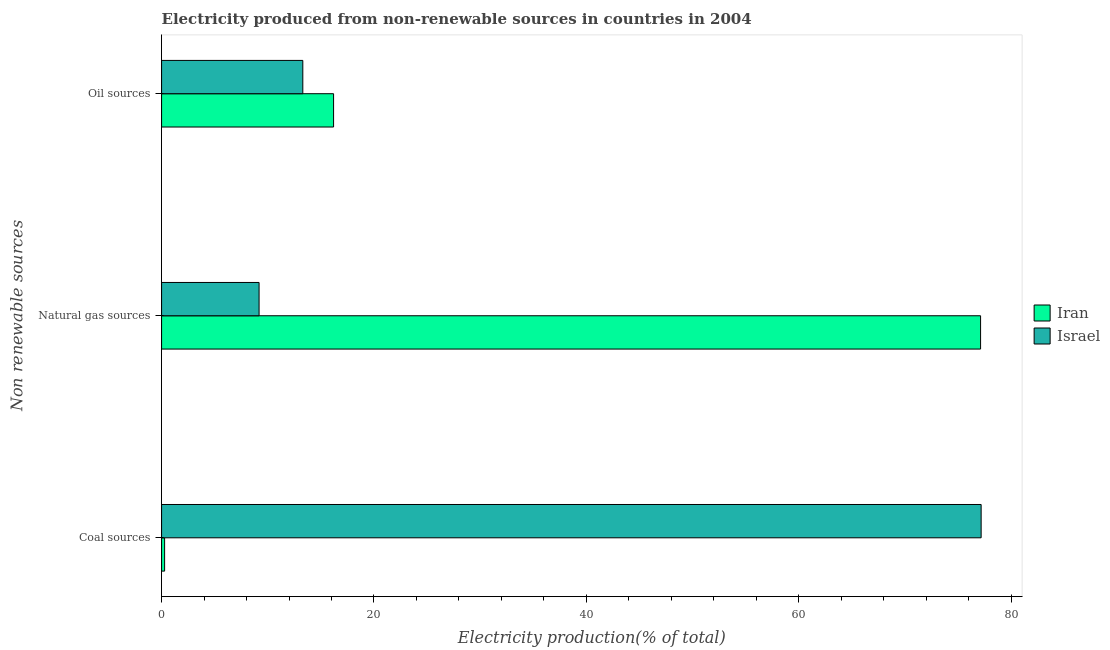How many groups of bars are there?
Offer a terse response. 3. Are the number of bars per tick equal to the number of legend labels?
Provide a succinct answer. Yes. How many bars are there on the 1st tick from the top?
Your answer should be compact. 2. What is the label of the 1st group of bars from the top?
Your answer should be compact. Oil sources. What is the percentage of electricity produced by natural gas in Iran?
Provide a succinct answer. 77.12. Across all countries, what is the maximum percentage of electricity produced by natural gas?
Give a very brief answer. 77.12. Across all countries, what is the minimum percentage of electricity produced by coal?
Offer a terse response. 0.29. In which country was the percentage of electricity produced by oil sources maximum?
Give a very brief answer. Iran. In which country was the percentage of electricity produced by coal minimum?
Ensure brevity in your answer.  Iran. What is the total percentage of electricity produced by coal in the graph?
Make the answer very short. 77.46. What is the difference between the percentage of electricity produced by coal in Israel and that in Iran?
Your answer should be compact. 76.89. What is the difference between the percentage of electricity produced by coal in Israel and the percentage of electricity produced by natural gas in Iran?
Offer a very short reply. 0.05. What is the average percentage of electricity produced by natural gas per country?
Your response must be concise. 43.15. What is the difference between the percentage of electricity produced by oil sources and percentage of electricity produced by coal in Israel?
Provide a short and direct response. -63.88. What is the ratio of the percentage of electricity produced by coal in Israel to that in Iran?
Offer a very short reply. 270.63. Is the percentage of electricity produced by coal in Iran less than that in Israel?
Your answer should be very brief. Yes. What is the difference between the highest and the second highest percentage of electricity produced by natural gas?
Provide a succinct answer. 67.94. What is the difference between the highest and the lowest percentage of electricity produced by coal?
Your answer should be compact. 76.89. Is the sum of the percentage of electricity produced by natural gas in Iran and Israel greater than the maximum percentage of electricity produced by oil sources across all countries?
Your response must be concise. Yes. What does the 2nd bar from the bottom in Coal sources represents?
Offer a very short reply. Israel. Is it the case that in every country, the sum of the percentage of electricity produced by coal and percentage of electricity produced by natural gas is greater than the percentage of electricity produced by oil sources?
Provide a succinct answer. Yes. How many bars are there?
Provide a short and direct response. 6. Are all the bars in the graph horizontal?
Provide a succinct answer. Yes. Does the graph contain grids?
Provide a succinct answer. No. Where does the legend appear in the graph?
Provide a succinct answer. Center right. How are the legend labels stacked?
Make the answer very short. Vertical. What is the title of the graph?
Offer a very short reply. Electricity produced from non-renewable sources in countries in 2004. What is the label or title of the Y-axis?
Your answer should be very brief. Non renewable sources. What is the Electricity production(% of total) in Iran in Coal sources?
Make the answer very short. 0.29. What is the Electricity production(% of total) in Israel in Coal sources?
Make the answer very short. 77.18. What is the Electricity production(% of total) in Iran in Natural gas sources?
Give a very brief answer. 77.12. What is the Electricity production(% of total) of Israel in Natural gas sources?
Provide a short and direct response. 9.18. What is the Electricity production(% of total) of Iran in Oil sources?
Provide a succinct answer. 16.2. What is the Electricity production(% of total) of Israel in Oil sources?
Keep it short and to the point. 13.3. Across all Non renewable sources, what is the maximum Electricity production(% of total) of Iran?
Make the answer very short. 77.12. Across all Non renewable sources, what is the maximum Electricity production(% of total) in Israel?
Offer a terse response. 77.18. Across all Non renewable sources, what is the minimum Electricity production(% of total) in Iran?
Your answer should be compact. 0.29. Across all Non renewable sources, what is the minimum Electricity production(% of total) of Israel?
Give a very brief answer. 9.18. What is the total Electricity production(% of total) in Iran in the graph?
Offer a very short reply. 93.61. What is the total Electricity production(% of total) in Israel in the graph?
Offer a terse response. 99.66. What is the difference between the Electricity production(% of total) of Iran in Coal sources and that in Natural gas sources?
Provide a short and direct response. -76.84. What is the difference between the Electricity production(% of total) in Israel in Coal sources and that in Natural gas sources?
Offer a very short reply. 67.99. What is the difference between the Electricity production(% of total) of Iran in Coal sources and that in Oil sources?
Your answer should be compact. -15.91. What is the difference between the Electricity production(% of total) of Israel in Coal sources and that in Oil sources?
Offer a terse response. 63.88. What is the difference between the Electricity production(% of total) of Iran in Natural gas sources and that in Oil sources?
Provide a short and direct response. 60.93. What is the difference between the Electricity production(% of total) of Israel in Natural gas sources and that in Oil sources?
Keep it short and to the point. -4.12. What is the difference between the Electricity production(% of total) of Iran in Coal sources and the Electricity production(% of total) of Israel in Natural gas sources?
Your response must be concise. -8.9. What is the difference between the Electricity production(% of total) in Iran in Coal sources and the Electricity production(% of total) in Israel in Oil sources?
Make the answer very short. -13.01. What is the difference between the Electricity production(% of total) of Iran in Natural gas sources and the Electricity production(% of total) of Israel in Oil sources?
Offer a terse response. 63.82. What is the average Electricity production(% of total) of Iran per Non renewable sources?
Your response must be concise. 31.2. What is the average Electricity production(% of total) of Israel per Non renewable sources?
Ensure brevity in your answer.  33.22. What is the difference between the Electricity production(% of total) of Iran and Electricity production(% of total) of Israel in Coal sources?
Ensure brevity in your answer.  -76.89. What is the difference between the Electricity production(% of total) of Iran and Electricity production(% of total) of Israel in Natural gas sources?
Offer a very short reply. 67.94. What is the difference between the Electricity production(% of total) in Iran and Electricity production(% of total) in Israel in Oil sources?
Keep it short and to the point. 2.9. What is the ratio of the Electricity production(% of total) in Iran in Coal sources to that in Natural gas sources?
Provide a short and direct response. 0. What is the ratio of the Electricity production(% of total) of Israel in Coal sources to that in Natural gas sources?
Ensure brevity in your answer.  8.41. What is the ratio of the Electricity production(% of total) in Iran in Coal sources to that in Oil sources?
Your answer should be very brief. 0.02. What is the ratio of the Electricity production(% of total) in Israel in Coal sources to that in Oil sources?
Provide a short and direct response. 5.8. What is the ratio of the Electricity production(% of total) of Iran in Natural gas sources to that in Oil sources?
Your answer should be very brief. 4.76. What is the ratio of the Electricity production(% of total) of Israel in Natural gas sources to that in Oil sources?
Your response must be concise. 0.69. What is the difference between the highest and the second highest Electricity production(% of total) in Iran?
Provide a short and direct response. 60.93. What is the difference between the highest and the second highest Electricity production(% of total) in Israel?
Give a very brief answer. 63.88. What is the difference between the highest and the lowest Electricity production(% of total) of Iran?
Your response must be concise. 76.84. What is the difference between the highest and the lowest Electricity production(% of total) in Israel?
Your answer should be compact. 67.99. 